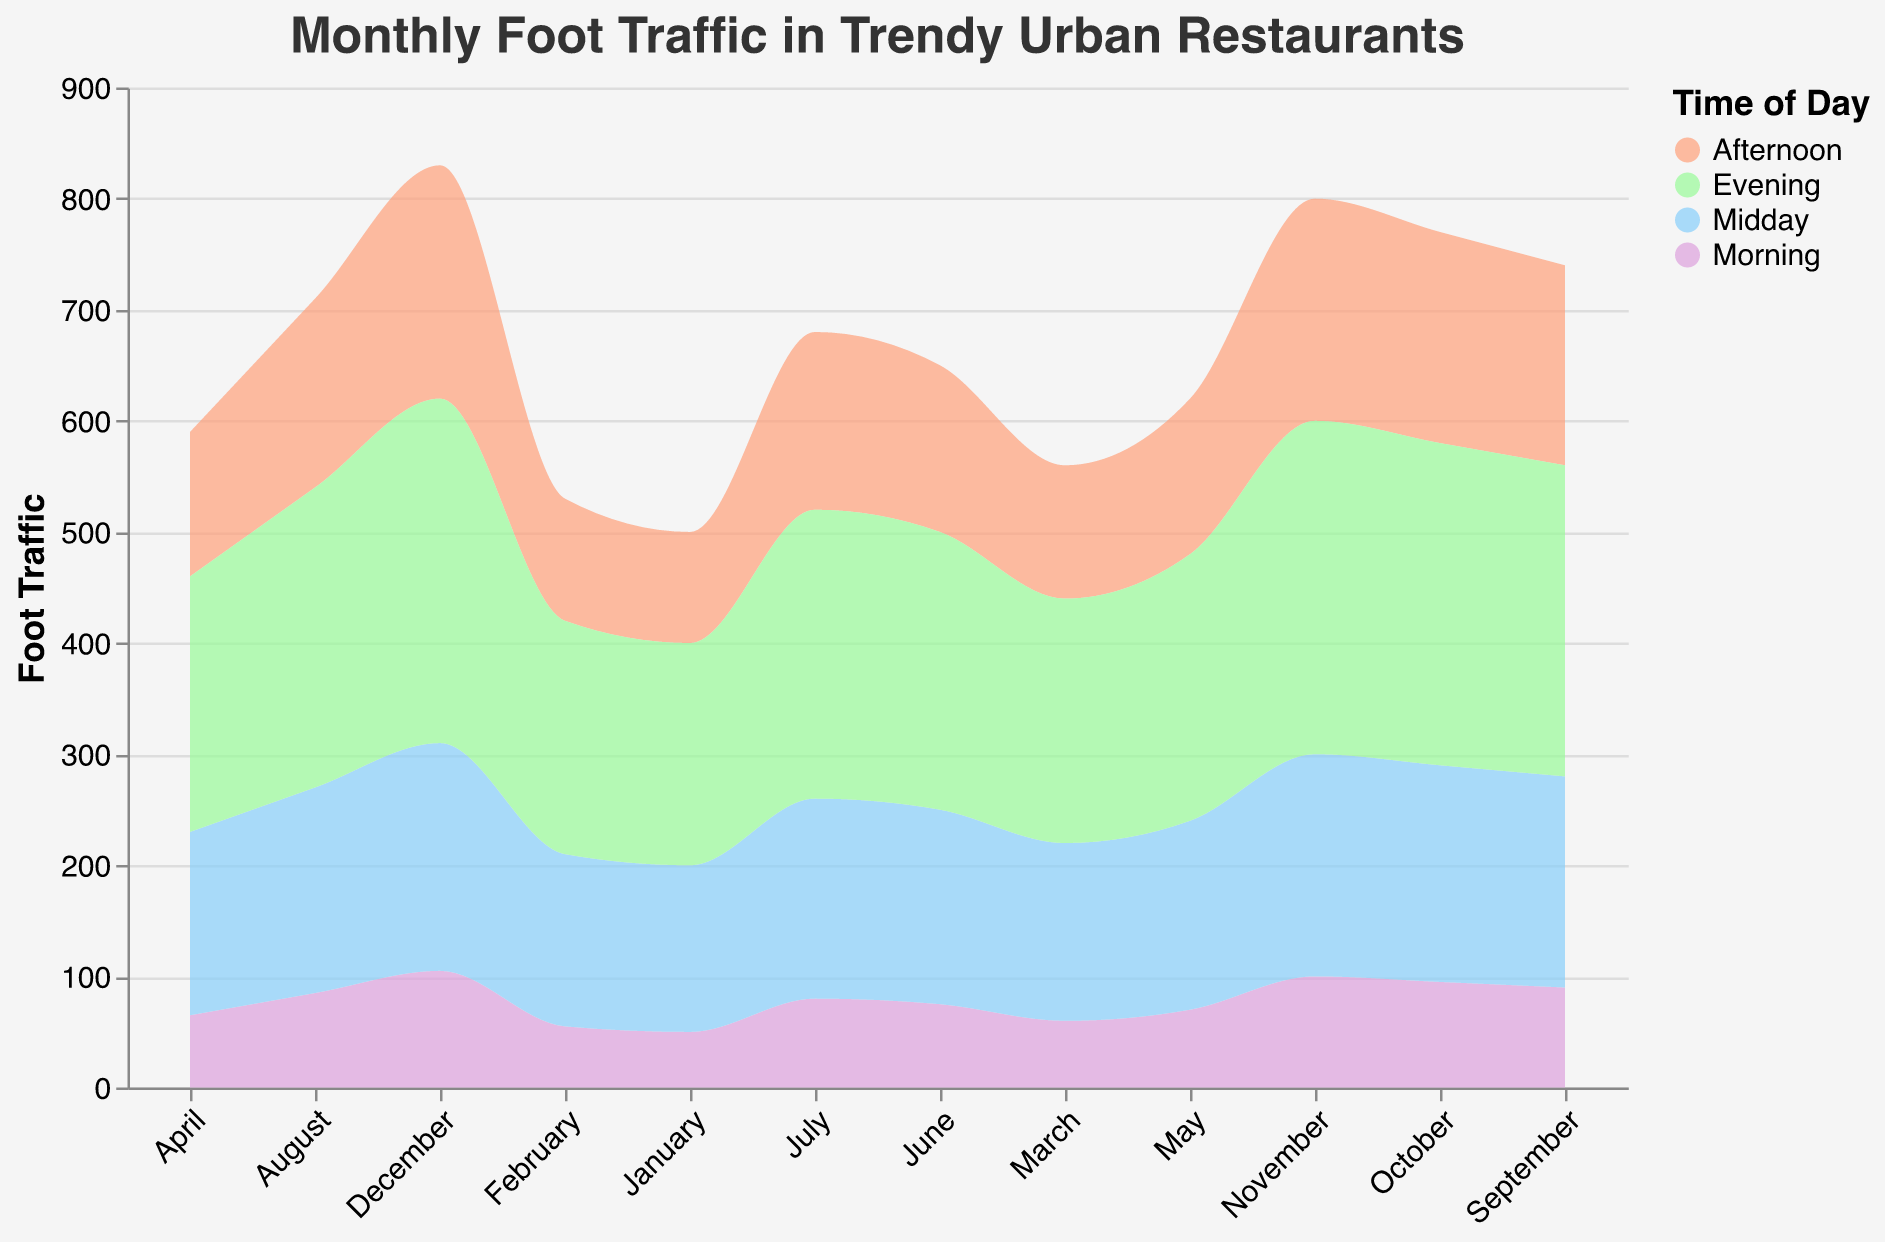What's the title of the chart? The title of the chart is centrally positioned at the top and is displayed in a distinctive font and color.
Answer: Monthly Foot Traffic in Trendy Urban Restaurants How many time-of-day categories are there in the chart? The legend on the right-hand side lists the different time-of-day categories, each represented by a different color.
Answer: Four Which month has the highest foot traffic in the Morning time category? By analyzing the area chart and looking at the Morning category, the peak value occurs in December.
Answer: December What is the overall trend in Evening foot traffic from January to December? Observing the Evening area, it shows a consistent upward trend starting in January and reaching its highest point in December.
Answer: Increasing For the Afternoon time category, how much does the foot traffic increase from January to June? In January, the Afternoon foot traffic is 100, and in June, it is 150. The difference is 150 - 100.
Answer: 50 Compare the Midday foot traffic in May and August. Which month has higher traffic and by how much? From the chart, we see that in May, the Midday foot traffic is 170, and in August, it is 185. The difference is 185 - 170.
Answer: August by 15 Which time-of-day category consistently has the lowest foot traffic throughout the year? Assessing all the shaded areas, the Morning category consistently has the lowest values in each month.
Answer: Morning What is the average foot traffic in the Afternoon category across the entire year? Add up the foot traffic for each month in the Afternoon category (100 + 110 + 120 + 130 + 140 + 150 + 160 + 170 + 180 + 190 + 200 + 210) and divide by 12. The sum is 1860, so the average is 1860/12.
Answer: 155 Which month sees the most significant total increase in foot traffic across all time-of-day categories? Calculate the total foot traffic for each month by adding the foot traffic of all categories. The comparisons show that December has the highest increase (105 + 205 + 210 + 310).
Answer: December How does the foot traffic in Morning compare to Evening in October? In October, Morning foot traffic is 95, whereas Evening foot traffic is 290. Evening outperforms Morning by a significant margin.
Answer: Evening by 195 Which month has the least variation in foot traffic across different times of the day, and what is this variation? Calculate the range for each month (max - min) in traffic numbers. For most months, Evening traffic vastly exceeds Morning traffic, making November the month with the least variation (105 difference).
Answer: November, 210 